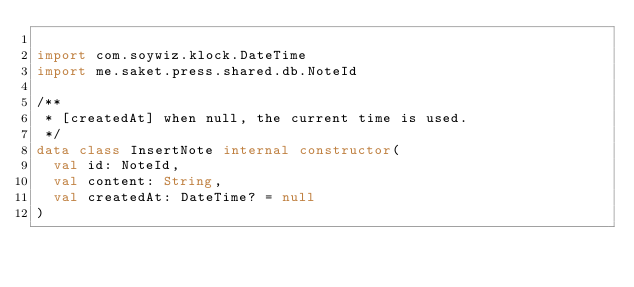<code> <loc_0><loc_0><loc_500><loc_500><_Kotlin_>
import com.soywiz.klock.DateTime
import me.saket.press.shared.db.NoteId

/**
 * [createdAt] when null, the current time is used.
 */
data class InsertNote internal constructor(
  val id: NoteId,
  val content: String,
  val createdAt: DateTime? = null
)
</code> 